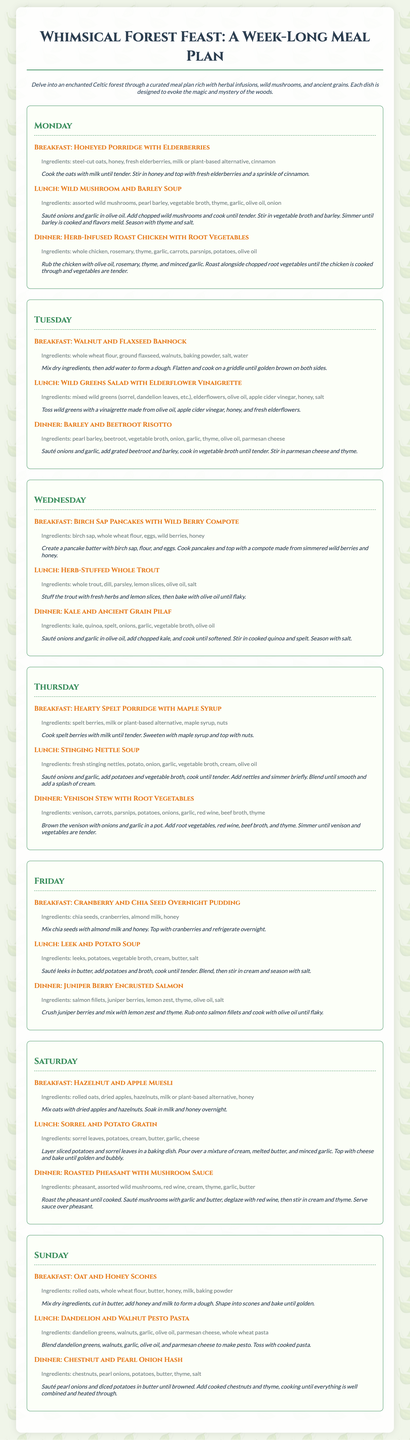What is the title of the meal plan? The title is the main heading presented at the top of the document.
Answer: Whimsical Forest Feast: A Week-Long Meal Plan How many days does the meal plan cover? The meal plan is organized into sections that represent each day of the week.
Answer: 7 days What type of grains are highlighted in the meals? The document emphasizes specific types of grains that are central to the recipes.
Answer: Ancient grains What is the main ingredient in the "Wild Mushroom and Barley Soup"? The soup’s title indicates the key ingredient that defines the dish.
Answer: Wild mushrooms Which meal features elderberries as an ingredient? The breakfast section for Monday specifically mentions a dish that includes elderberries.
Answer: Honeyed Porridge with Elderberries How is the venison prepared in the Friday dinner? The description for the dinner provides details on how the venison dish is cooked.
Answer: Stew What sweetener is used in the "Cranberry and Chia Seed Overnight Pudding"? The ingredients list specifies what sweetening agent is included in the pudding.
Answer: Honey 